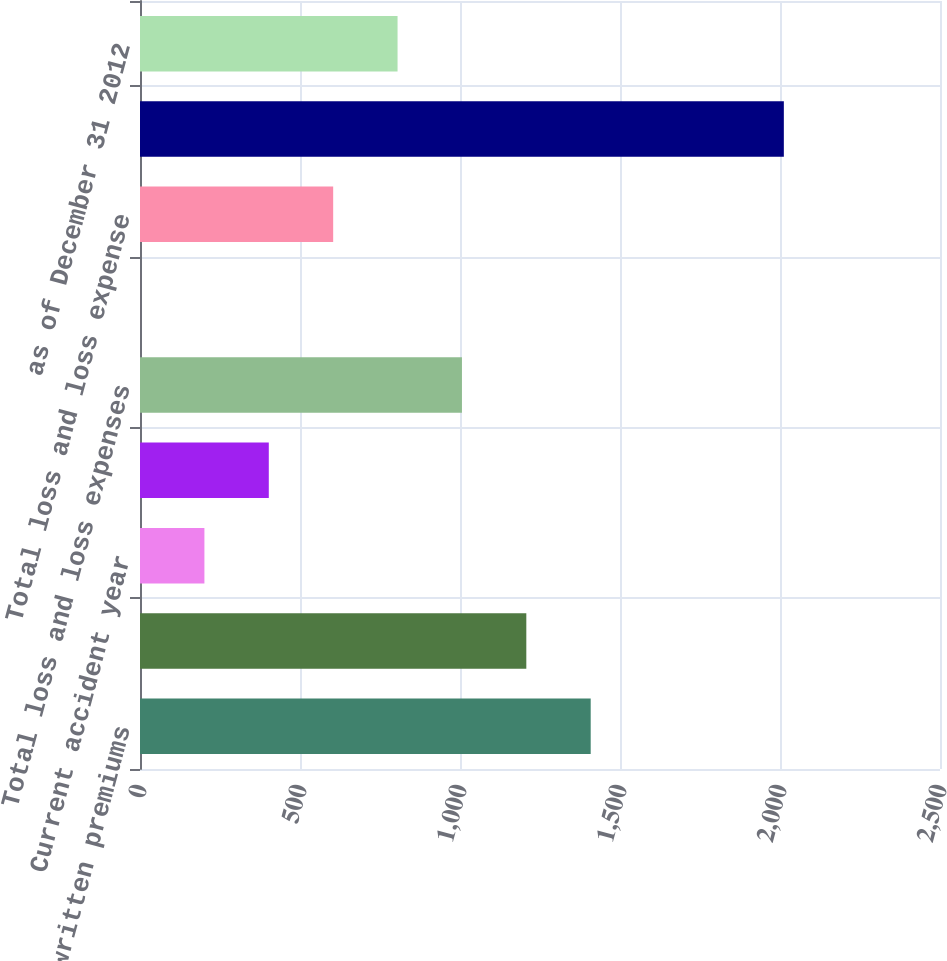<chart> <loc_0><loc_0><loc_500><loc_500><bar_chart><fcel>Net written premiums<fcel>Current accident year before<fcel>Current accident year<fcel>Prior accident years before<fcel>Total loss and loss expenses<fcel>Prior accident years<fcel>Total loss and loss expense<fcel>Accident Year<fcel>as of December 31 2012<nl><fcel>1408.43<fcel>1207.24<fcel>201.29<fcel>402.48<fcel>1006.05<fcel>0.1<fcel>603.67<fcel>2012<fcel>804.86<nl></chart> 